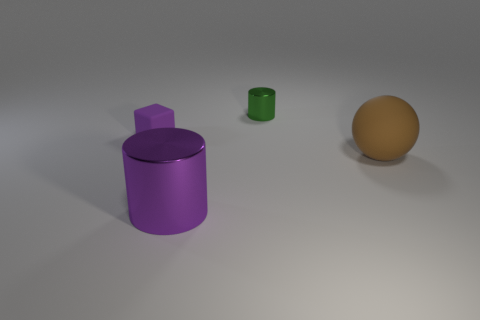Subtract all green cylinders. How many cylinders are left? 1 Add 1 big balls. How many objects exist? 5 Subtract 1 cylinders. How many cylinders are left? 1 Subtract all blocks. How many objects are left? 3 Subtract all purple cylinders. Subtract all small metal cylinders. How many objects are left? 2 Add 2 small matte cubes. How many small matte cubes are left? 3 Add 2 green metal things. How many green metal things exist? 3 Subtract 0 red blocks. How many objects are left? 4 Subtract all gray blocks. Subtract all yellow cylinders. How many blocks are left? 1 